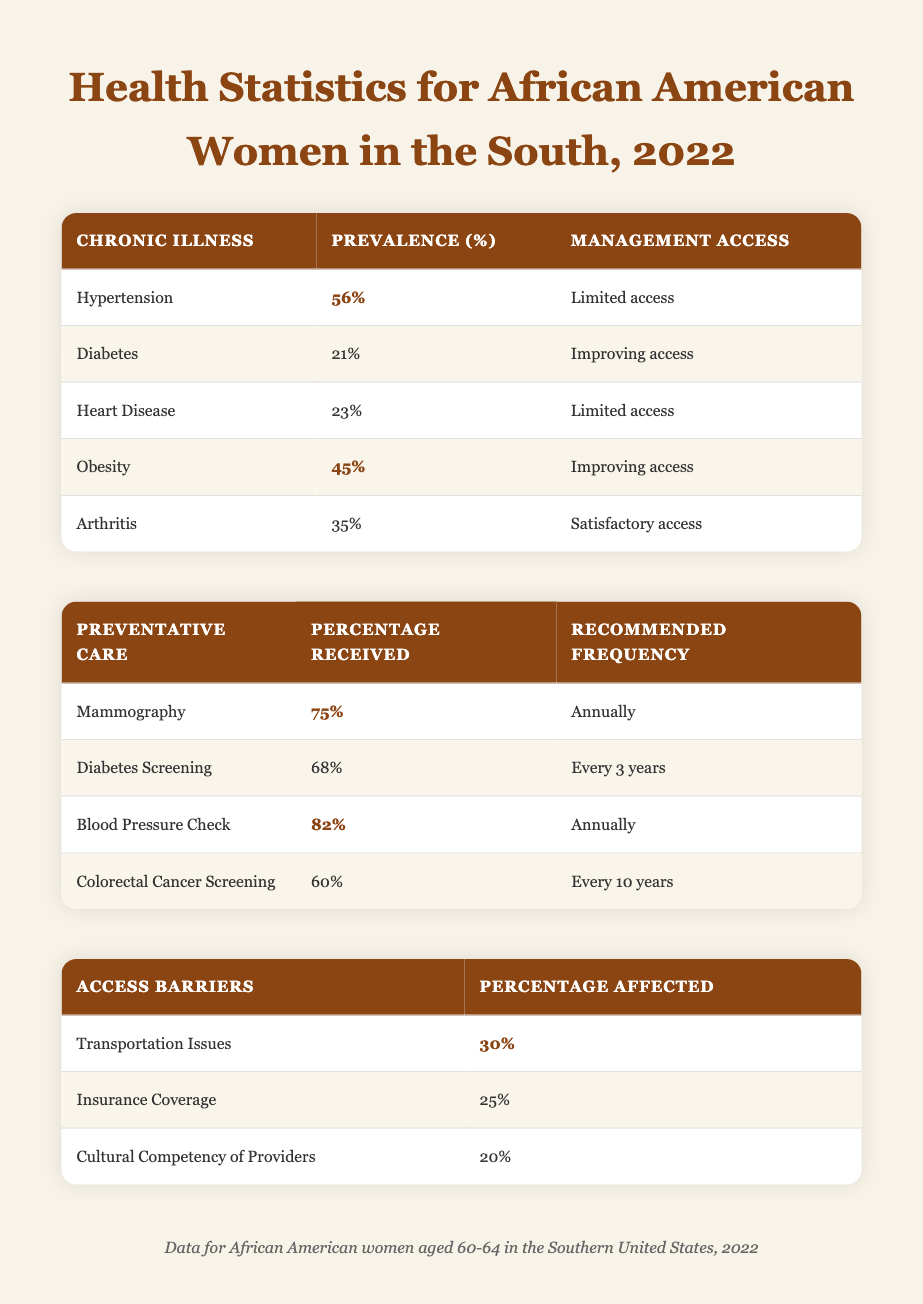What's the prevalence percentage of Hypertension? From the table under the "Chronic Illnesses" section, the prevalence percentage of Hypertension is listed as 56%.
Answer: 56% What percentage of African American women aged 60-64 received Blood Pressure Checks? The table detailing "Preventative Care" indicates that the percentage of women receiving Blood Pressure Checks is 82%.
Answer: 82% Is the management access for Arthritis satisfactory? According to the data, the management access for Arthritis is classified as "Satisfactory access," which confirms that it is indeed satisfactory.
Answer: Yes What is the difference in prevalence percentage between Obesity and Diabetes? The prevalence percentage for Obesity is 45% and for Diabetes it is 21%. The difference is calculated as 45 - 21 = 24%.
Answer: 24% How many chronic illnesses have limited access to management? From the "Chronic Illnesses" section, Hypertension and Heart Disease both have "Limited access," totaling 2 illnesses.
Answer: 2 What percentage of women faced Transportation Issues as a barrier? The table in the "Access Barriers" category shows that 30% of women faced Transportation Issues.
Answer: 30% Which preventative care measure had the lowest percentage received? Reviewing the "Preventative Care" table, Colorectal Cancer Screening has the lowest percentage received at 60%.
Answer: 60% What is the average percentage of preventative care received for Mammography and Diabetes Screening? The percentages received for Mammography and Diabetes Screening are 75% and 68%, respectively. To find the average, we add these values (75 + 68 = 143) and divide by 2. Thus, the average is 143/2 = 71.5%.
Answer: 71.5% Is it true that less than half of the women received Colorectal Cancer Screening? The percentage received for Colorectal Cancer Screening is 60%, which is not less than half. Therefore, the statement is false.
Answer: No 